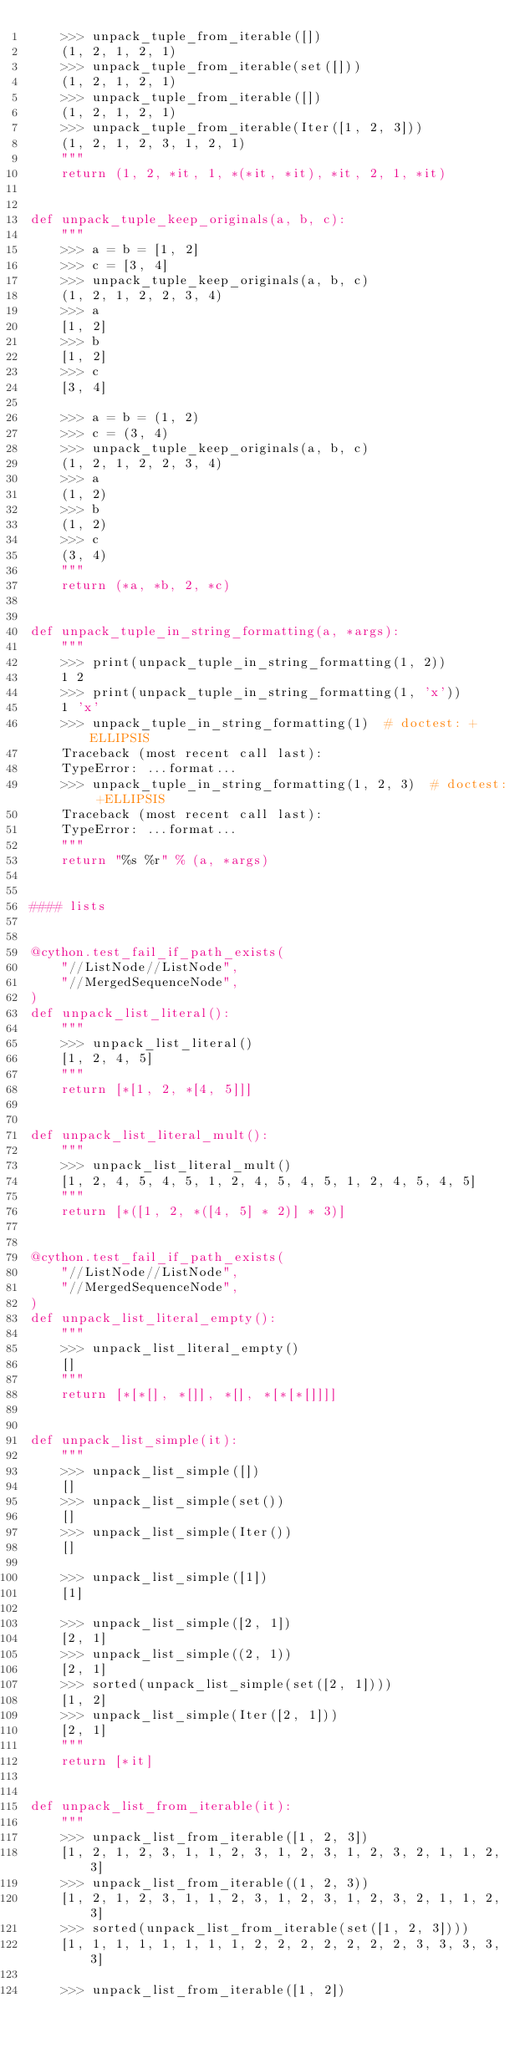<code> <loc_0><loc_0><loc_500><loc_500><_Cython_>    >>> unpack_tuple_from_iterable([])
    (1, 2, 1, 2, 1)
    >>> unpack_tuple_from_iterable(set([]))
    (1, 2, 1, 2, 1)
    >>> unpack_tuple_from_iterable([])
    (1, 2, 1, 2, 1)
    >>> unpack_tuple_from_iterable(Iter([1, 2, 3]))
    (1, 2, 1, 2, 3, 1, 2, 1)
    """
    return (1, 2, *it, 1, *(*it, *it), *it, 2, 1, *it)


def unpack_tuple_keep_originals(a, b, c):
    """
    >>> a = b = [1, 2]
    >>> c = [3, 4]
    >>> unpack_tuple_keep_originals(a, b, c)
    (1, 2, 1, 2, 2, 3, 4)
    >>> a
    [1, 2]
    >>> b
    [1, 2]
    >>> c
    [3, 4]

    >>> a = b = (1, 2)
    >>> c = (3, 4)
    >>> unpack_tuple_keep_originals(a, b, c)
    (1, 2, 1, 2, 2, 3, 4)
    >>> a
    (1, 2)
    >>> b
    (1, 2)
    >>> c
    (3, 4)
    """
    return (*a, *b, 2, *c)


def unpack_tuple_in_string_formatting(a, *args):
    """
    >>> print(unpack_tuple_in_string_formatting(1, 2))
    1 2
    >>> print(unpack_tuple_in_string_formatting(1, 'x'))
    1 'x'
    >>> unpack_tuple_in_string_formatting(1)  # doctest: +ELLIPSIS
    Traceback (most recent call last):
    TypeError: ...format...
    >>> unpack_tuple_in_string_formatting(1, 2, 3)  # doctest: +ELLIPSIS
    Traceback (most recent call last):
    TypeError: ...format...
    """
    return "%s %r" % (a, *args)


#### lists


@cython.test_fail_if_path_exists(
    "//ListNode//ListNode",
    "//MergedSequenceNode",
)
def unpack_list_literal():
    """
    >>> unpack_list_literal()
    [1, 2, 4, 5]
    """
    return [*[1, 2, *[4, 5]]]


def unpack_list_literal_mult():
    """
    >>> unpack_list_literal_mult()
    [1, 2, 4, 5, 4, 5, 1, 2, 4, 5, 4, 5, 1, 2, 4, 5, 4, 5]
    """
    return [*([1, 2, *([4, 5] * 2)] * 3)]


@cython.test_fail_if_path_exists(
    "//ListNode//ListNode",
    "//MergedSequenceNode",
)
def unpack_list_literal_empty():
    """
    >>> unpack_list_literal_empty()
    []
    """
    return [*[*[], *[]], *[], *[*[*[]]]]


def unpack_list_simple(it):
    """
    >>> unpack_list_simple([])
    []
    >>> unpack_list_simple(set())
    []
    >>> unpack_list_simple(Iter())
    []

    >>> unpack_list_simple([1])
    [1]

    >>> unpack_list_simple([2, 1])
    [2, 1]
    >>> unpack_list_simple((2, 1))
    [2, 1]
    >>> sorted(unpack_list_simple(set([2, 1])))
    [1, 2]
    >>> unpack_list_simple(Iter([2, 1]))
    [2, 1]
    """
    return [*it]


def unpack_list_from_iterable(it):
    """
    >>> unpack_list_from_iterable([1, 2, 3])
    [1, 2, 1, 2, 3, 1, 1, 2, 3, 1, 2, 3, 1, 2, 3, 2, 1, 1, 2, 3]
    >>> unpack_list_from_iterable((1, 2, 3))
    [1, 2, 1, 2, 3, 1, 1, 2, 3, 1, 2, 3, 1, 2, 3, 2, 1, 1, 2, 3]
    >>> sorted(unpack_list_from_iterable(set([1, 2, 3])))
    [1, 1, 1, 1, 1, 1, 1, 1, 2, 2, 2, 2, 2, 2, 2, 3, 3, 3, 3, 3]

    >>> unpack_list_from_iterable([1, 2])</code> 